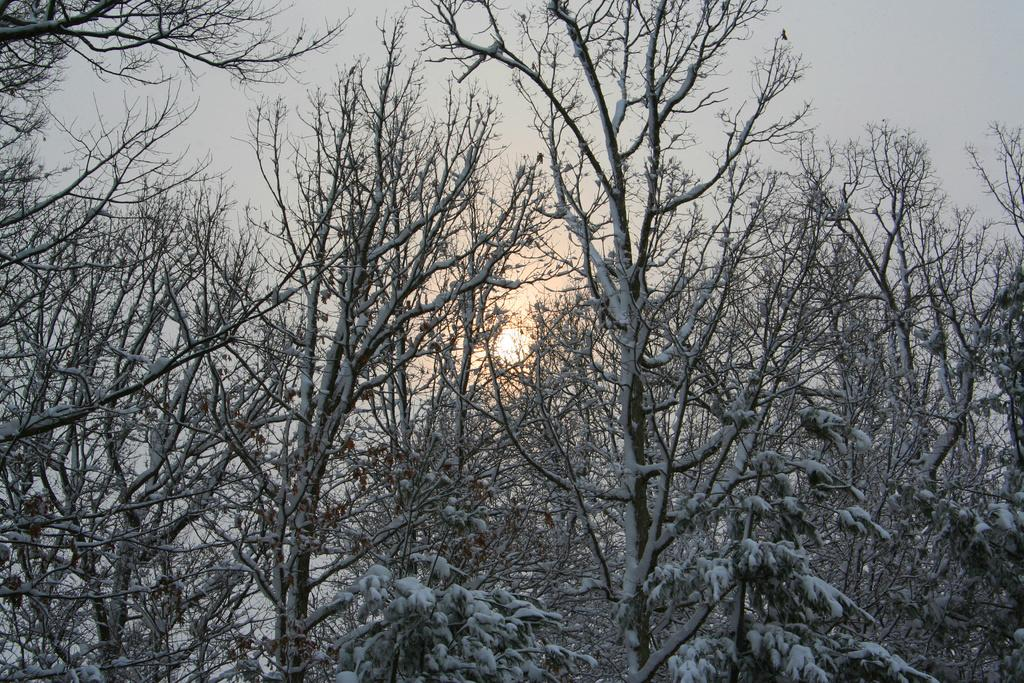What type of vegetation can be seen in the image? There are trees in the image. What is covering the trees in the image? There is snow on the trees. What is visible at the top of the image? The sky is visible at the top of the image. What celestial body can be seen in the sky? The sun is present in the sky. What language are the ants communicating in while walking on the trees in the image? There are no ants present in the image, and therefore no communication or walking can be observed. 